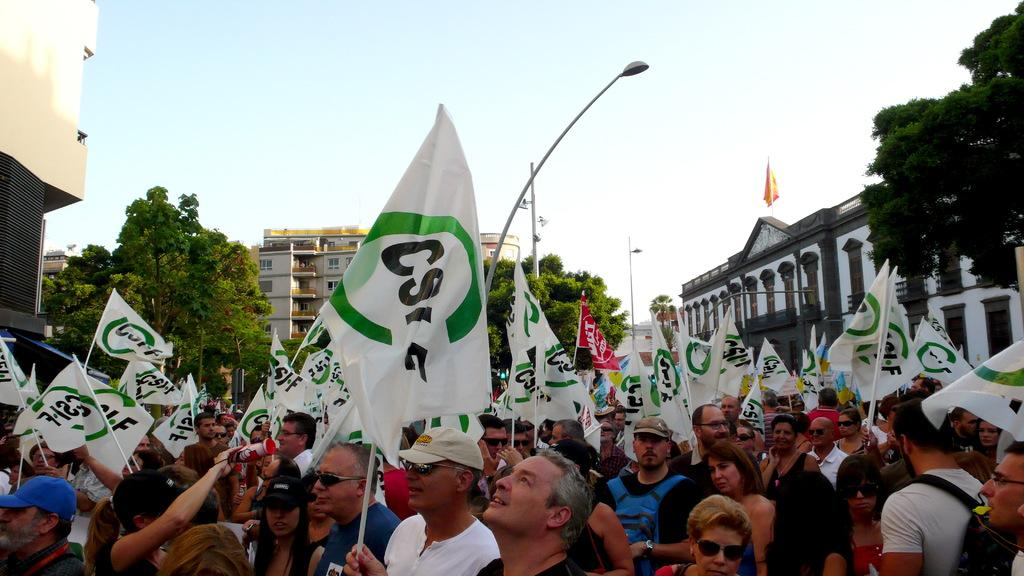How many people are in the image? There is a group of people in the image, but the exact number cannot be determined from the provided facts. What can be seen in the image besides the group of people? There are flags, buildings, trees, electric poles, and the sky visible in the background of the image. What type of structures are visible in the background of the image? There are buildings and electric poles visible in the background of the image. What is the natural environment visible in the image? The natural environment includes trees and the sky. What type of guitar is being played by the person in the image? There is no guitar present in the image. What property is being discussed in relation to the buildings in the image? The provided facts do not mention any property or discussion related to the buildings in the image. 